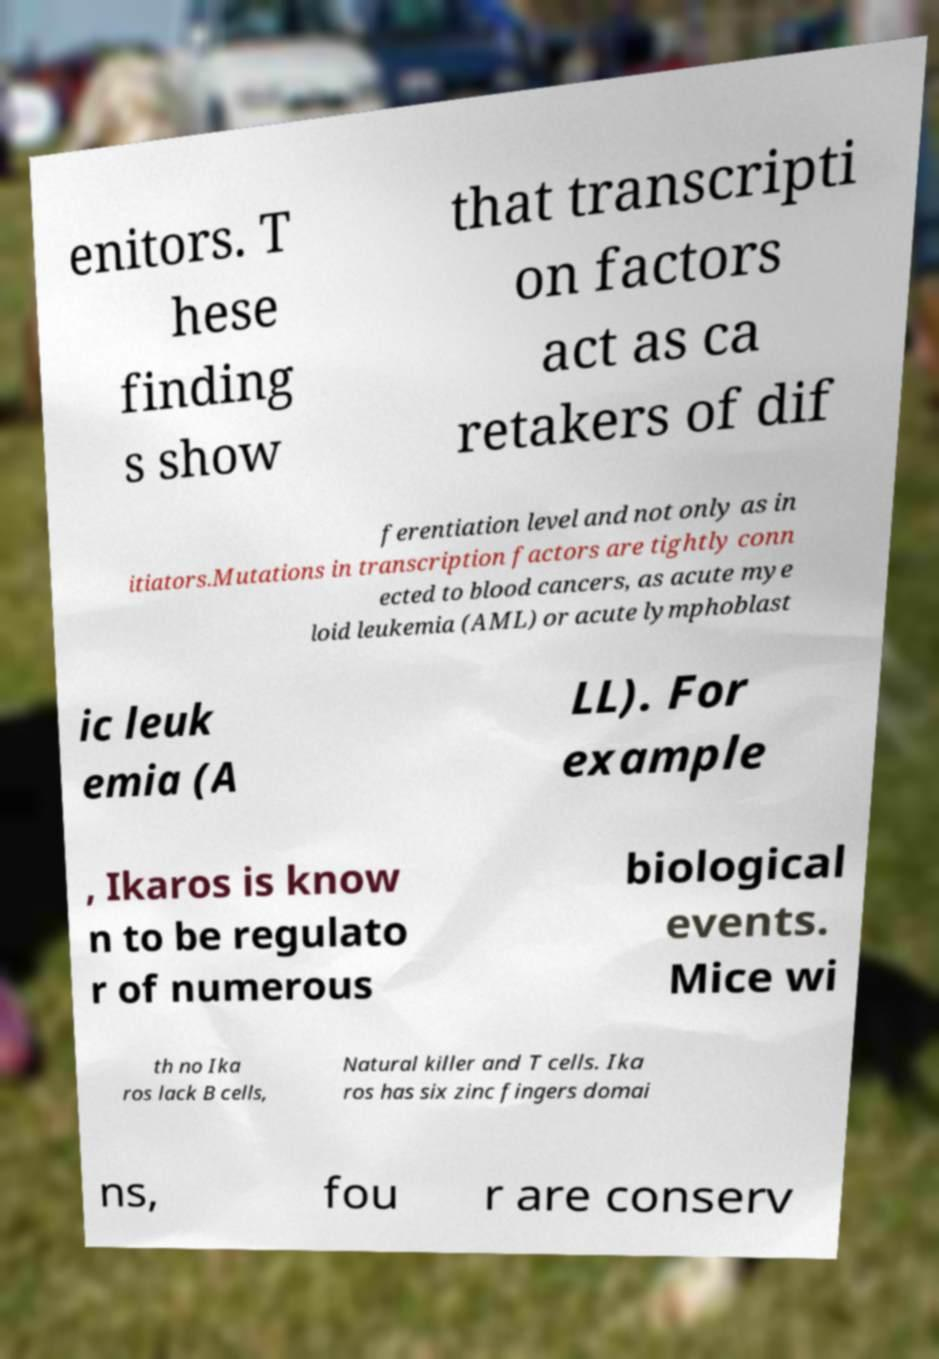For documentation purposes, I need the text within this image transcribed. Could you provide that? enitors. T hese finding s show that transcripti on factors act as ca retakers of dif ferentiation level and not only as in itiators.Mutations in transcription factors are tightly conn ected to blood cancers, as acute mye loid leukemia (AML) or acute lymphoblast ic leuk emia (A LL). For example , Ikaros is know n to be regulato r of numerous biological events. Mice wi th no Ika ros lack B cells, Natural killer and T cells. Ika ros has six zinc fingers domai ns, fou r are conserv 